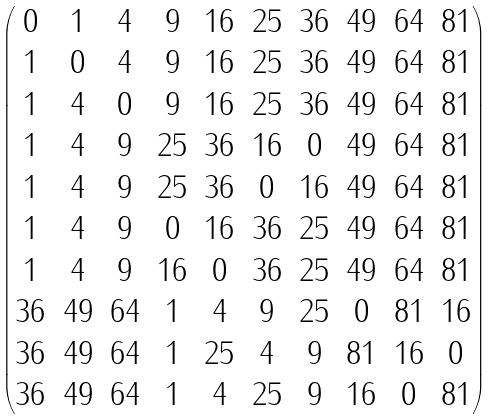Convert formula to latex. <formula><loc_0><loc_0><loc_500><loc_500>\begin{pmatrix} 0 & 1 & 4 & 9 & 1 6 & 2 5 & 3 6 & 4 9 & 6 4 & 8 1 \\ 1 & 0 & 4 & 9 & 1 6 & 2 5 & 3 6 & 4 9 & 6 4 & 8 1 \\ 1 & 4 & 0 & 9 & 1 6 & 2 5 & 3 6 & 4 9 & 6 4 & 8 1 \\ 1 & 4 & 9 & 2 5 & 3 6 & 1 6 & 0 & 4 9 & 6 4 & 8 1 \\ 1 & 4 & 9 & 2 5 & 3 6 & 0 & 1 6 & 4 9 & 6 4 & 8 1 \\ 1 & 4 & 9 & 0 & 1 6 & 3 6 & 2 5 & 4 9 & 6 4 & 8 1 \\ 1 & 4 & 9 & 1 6 & 0 & 3 6 & 2 5 & 4 9 & 6 4 & 8 1 \\ 3 6 & 4 9 & 6 4 & 1 & 4 & 9 & 2 5 & 0 & 8 1 & 1 6 \\ 3 6 & 4 9 & 6 4 & 1 & 2 5 & 4 & 9 & 8 1 & 1 6 & 0 \\ 3 6 & 4 9 & 6 4 & 1 & 4 & 2 5 & 9 & 1 6 & 0 & 8 1 \end{pmatrix}</formula> 